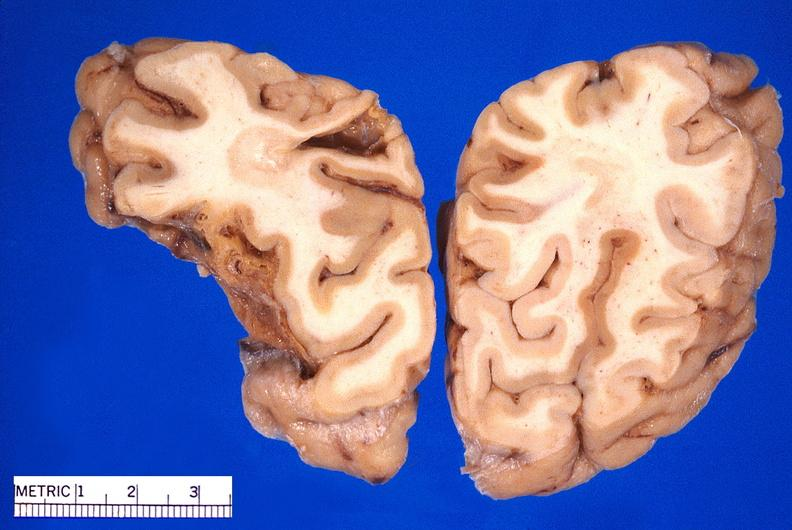what is present?
Answer the question using a single word or phrase. Nervous 